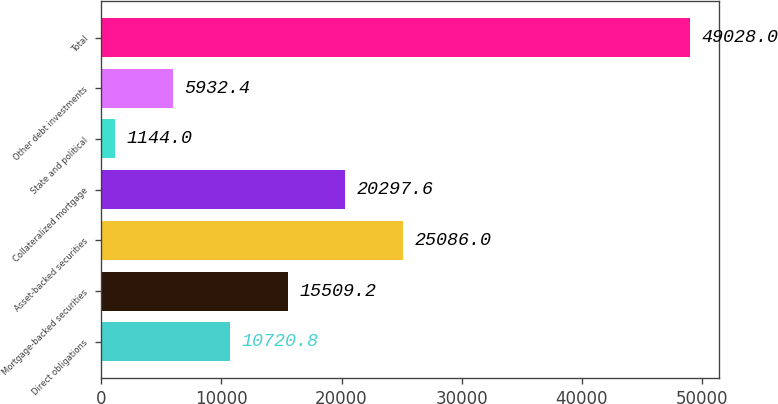Convert chart to OTSL. <chart><loc_0><loc_0><loc_500><loc_500><bar_chart><fcel>Direct obligations<fcel>Mortgage-backed securities<fcel>Asset-backed securities<fcel>Collateralized mortgage<fcel>State and political<fcel>Other debt investments<fcel>Total<nl><fcel>10720.8<fcel>15509.2<fcel>25086<fcel>20297.6<fcel>1144<fcel>5932.4<fcel>49028<nl></chart> 